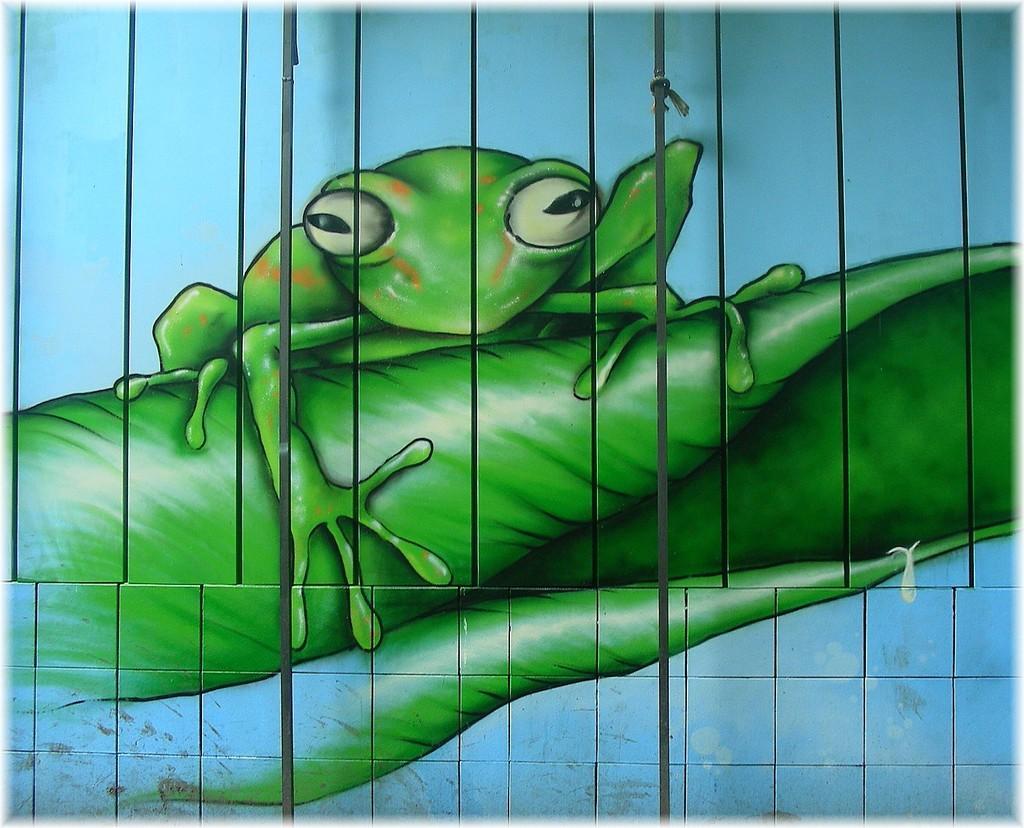Describe this image in one or two sentences. In this picture I can see painting on the wall looks like a frog on the leaf 